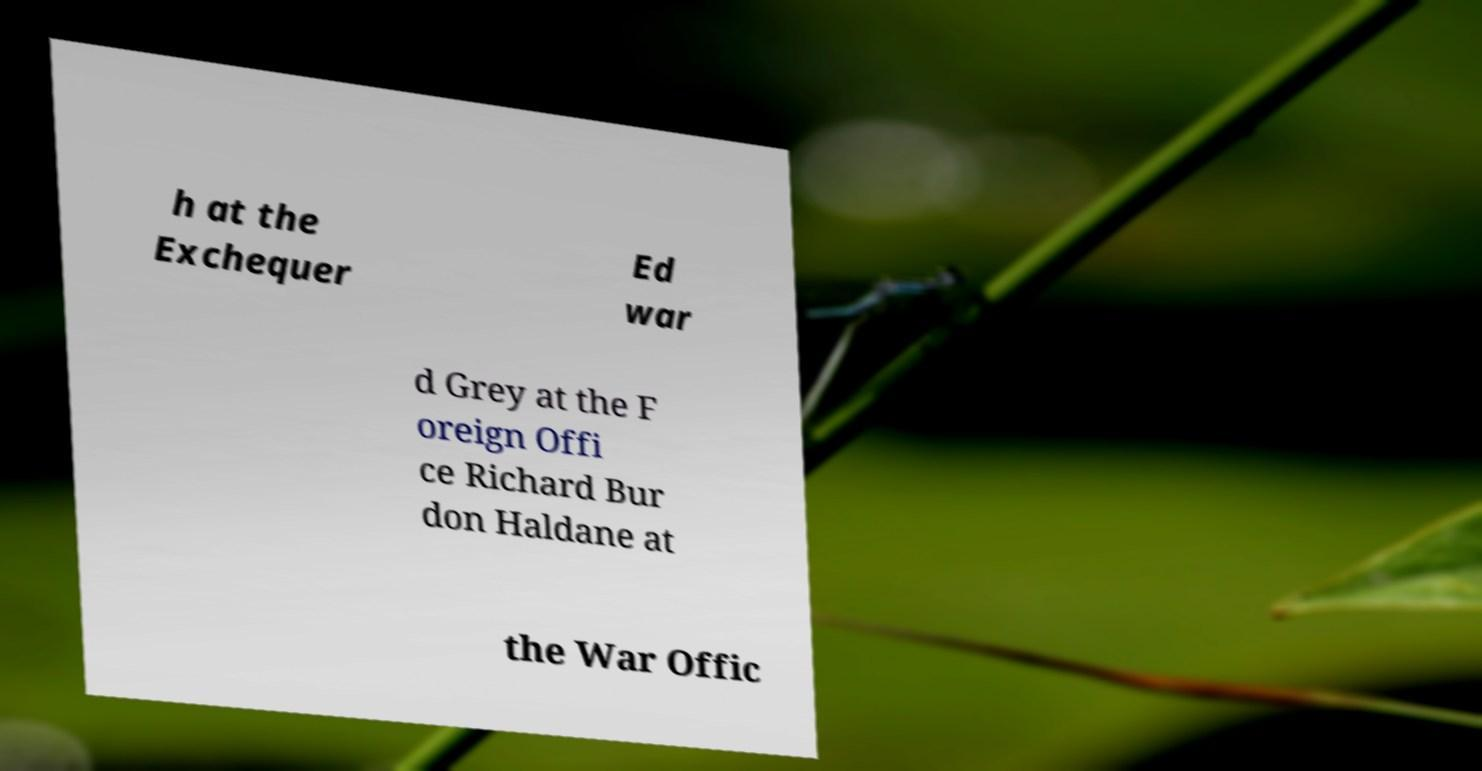Please read and relay the text visible in this image. What does it say? h at the Exchequer Ed war d Grey at the F oreign Offi ce Richard Bur don Haldane at the War Offic 